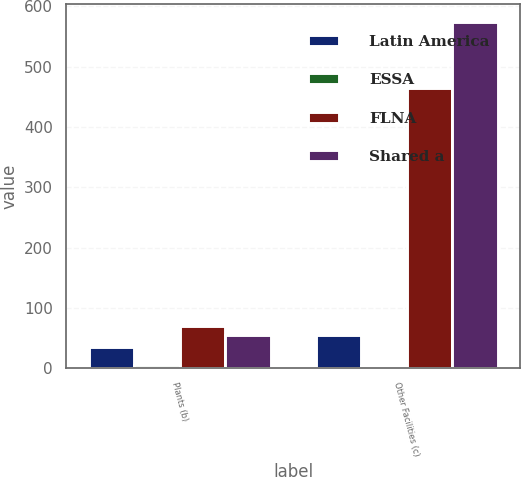Convert chart to OTSL. <chart><loc_0><loc_0><loc_500><loc_500><stacked_bar_chart><ecel><fcel>Plants (b)<fcel>Other Facilities (c)<nl><fcel>Latin America<fcel>35<fcel>55<nl><fcel>ESSA<fcel>5<fcel>3<nl><fcel>FLNA<fcel>70<fcel>465<nl><fcel>Shared a<fcel>55<fcel>575<nl></chart> 